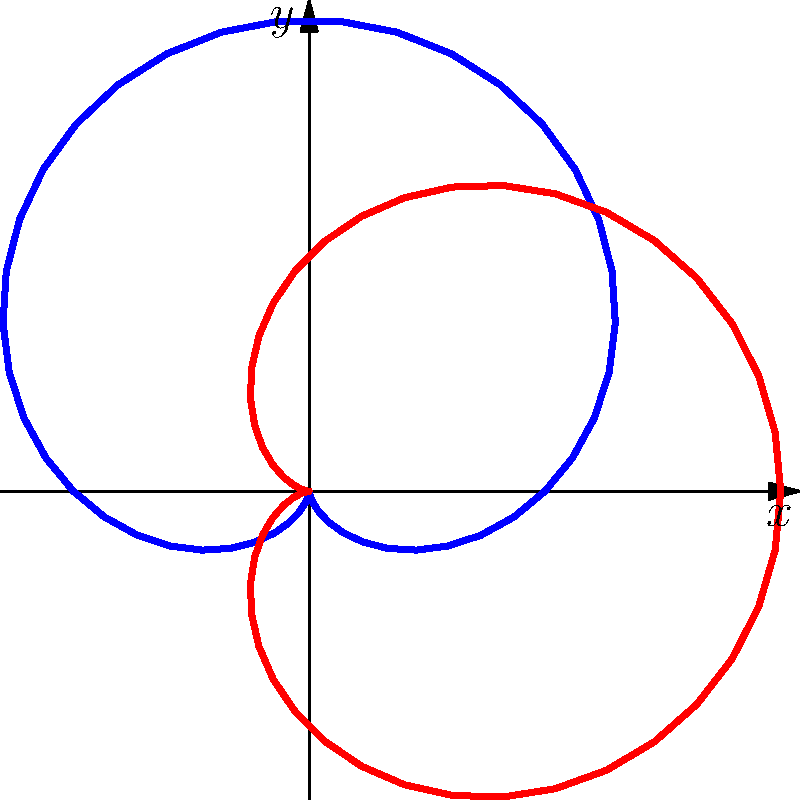In the polar plot representing social movement growth patterns, what mathematical relationship exists between the blue curve (Social Movement) and the red curve (Counter-Movement), and how might this inform your analysis of cyclical patterns in social justice movements? To answer this question, let's analyze the polar plot step-by-step:

1. The blue curve represents the Social Movement, given by the polar equation $r = 1 + \sin(\theta)$.

2. The red curve represents the Counter-Movement, given by the polar equation $r = 1 + \cos(\theta)$.

3. These two curves are related through a trigonometric identity:
   $\cos(\theta) = \sin(\theta + \frac{\pi}{2})$

4. This relationship means that the Counter-Movement curve is a 90-degree (or $\frac{\pi}{2}$ radians) rotation of the Social Movement curve.

5. In the context of social movements, this relationship suggests a cyclical pattern where:
   a) As one movement reaches its peak, the other is at its median strength.
   b) When one movement is at its minimum, the other is at its median strength.
   c) The movements are always out of phase with each other by 90 degrees.

6. This pattern implies that social movements and counter-movements may have a predictable, cyclical relationship, where the growth of one may trigger the emergence or strengthening of the other.

7. For a journalist covering social justice issues, this visualization could provide insights into:
   a) The timing and dynamics of social movements and their opposing forces.
   b) Potential predictions for the ebb and flow of different social justice movements.
   c) The interconnected nature of social movements and their counter-movements in a broader historical context.
Answer: 90-degree phase shift, indicating cyclical, interconnected growth patterns of movements and counter-movements. 